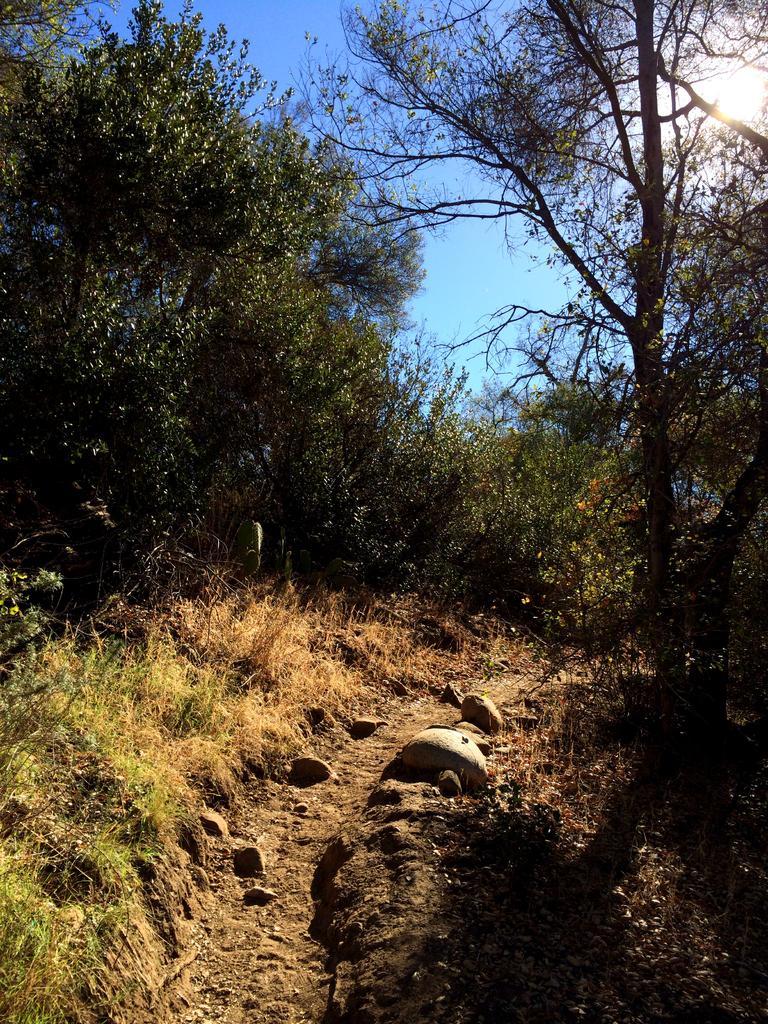Can you describe this image briefly? In this image I can see some rocks and grass on the ground. In the background I can see many trees, clouds and the sky. 